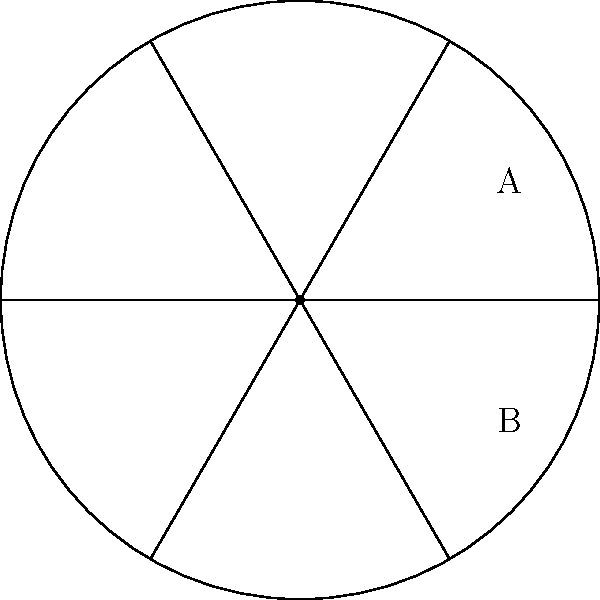A circular area needs to be divided into equal sectors for a six-person team to coordinate their movement during a high-risk operation. If the radius of the circular area is 10 meters, and two adjacent team members (A and B) are positioned 4 meters apart along the circumference, what is the central angle (in degrees) of each sector? To solve this problem, we'll follow these steps:

1) First, we need to understand that dividing the circle into 6 equal sectors means each central angle is $\frac{360°}{6} = 60°$.

2) Now, we need to verify if the given information about team members A and B matches this division.

3) We can use the formula for the arc length: $s = r\theta$, where
   $s$ is the arc length (distance between A and B along the circumference)
   $r$ is the radius
   $\theta$ is the central angle in radians

4) We're given $s = 4$ meters and $r = 10$ meters. We need to find $\theta$.

5) Rearranging the formula: $\theta = \frac{s}{r} = \frac{4}{10} = 0.4$ radians

6) Convert radians to degrees: $0.4 \text{ radians} \times \frac{180°}{\pi} \approx 22.92°$

7) This is approximately $\frac{1}{3}$ of 60°, which confirms that the distance between A and B represents $\frac{1}{3}$ of a 60° sector.

Therefore, the central angle of each sector is indeed 60°, matching our initial calculation for dividing the circle into 6 equal parts.
Answer: 60° 